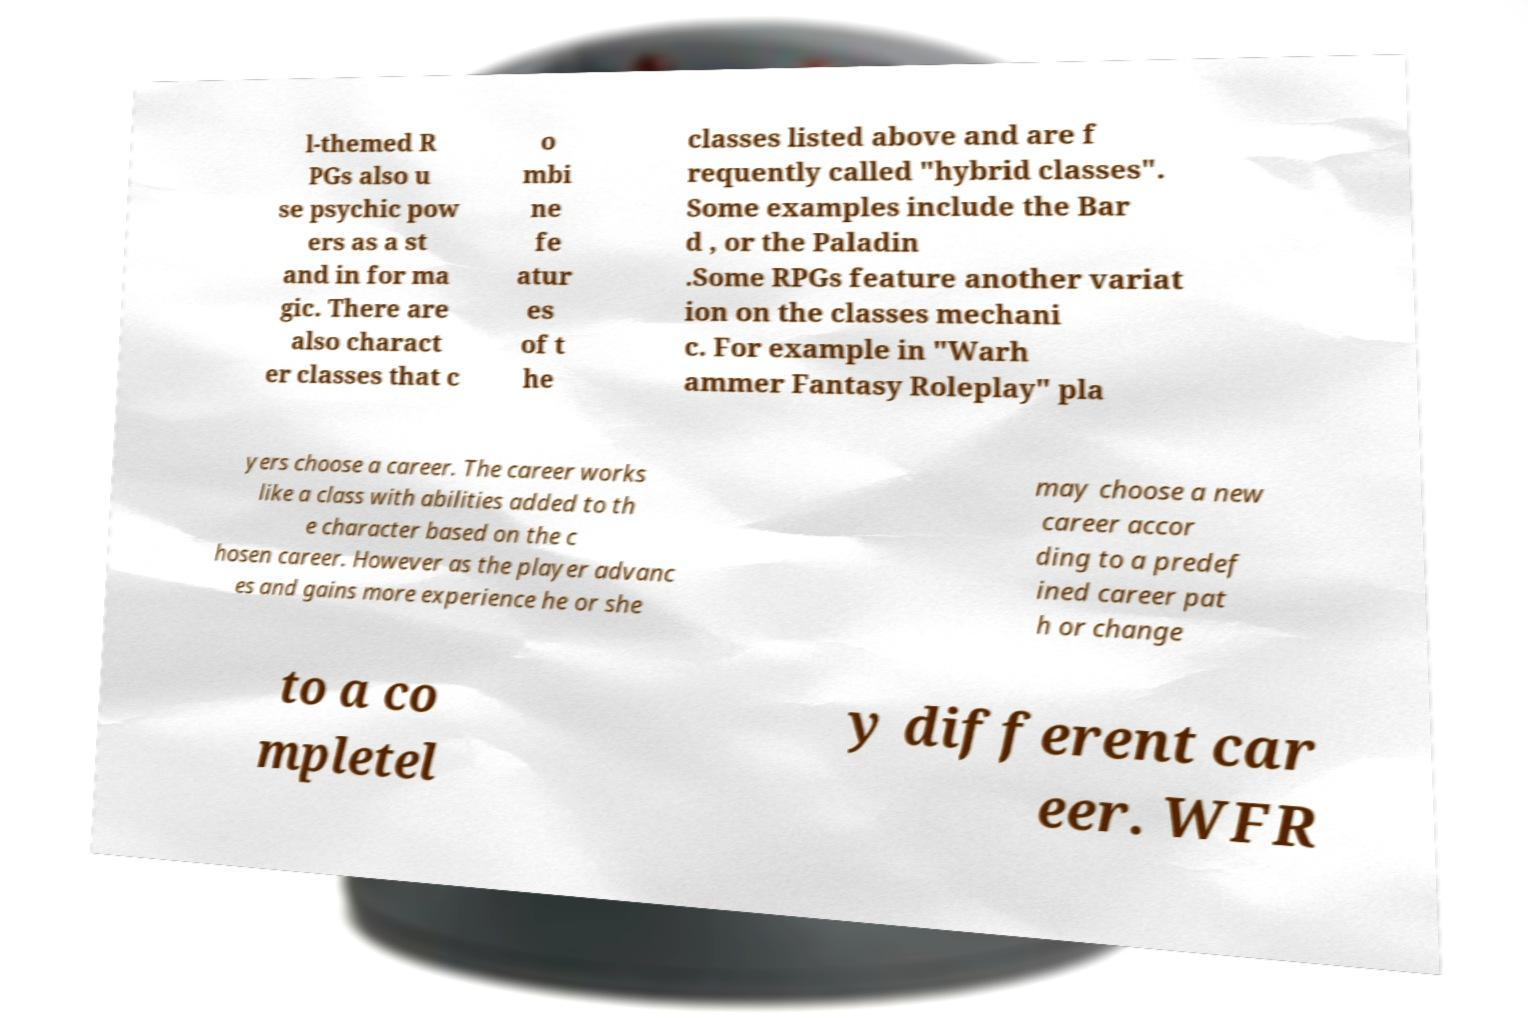Could you extract and type out the text from this image? l-themed R PGs also u se psychic pow ers as a st and in for ma gic. There are also charact er classes that c o mbi ne fe atur es of t he classes listed above and are f requently called "hybrid classes". Some examples include the Bar d , or the Paladin .Some RPGs feature another variat ion on the classes mechani c. For example in "Warh ammer Fantasy Roleplay" pla yers choose a career. The career works like a class with abilities added to th e character based on the c hosen career. However as the player advanc es and gains more experience he or she may choose a new career accor ding to a predef ined career pat h or change to a co mpletel y different car eer. WFR 